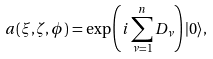Convert formula to latex. <formula><loc_0><loc_0><loc_500><loc_500>a ( \xi , \zeta , \phi ) = \exp \left ( i \sum _ { \nu = 1 } ^ { n } D _ { \nu } \right ) | 0 \rangle ,</formula> 